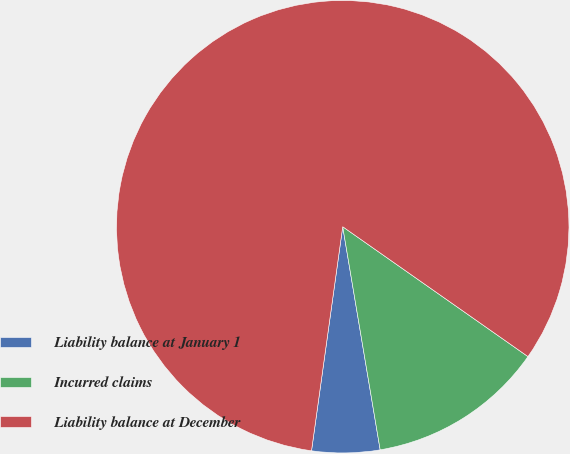Convert chart. <chart><loc_0><loc_0><loc_500><loc_500><pie_chart><fcel>Liability balance at January 1<fcel>Incurred claims<fcel>Liability balance at December<nl><fcel>4.85%<fcel>12.62%<fcel>82.52%<nl></chart> 